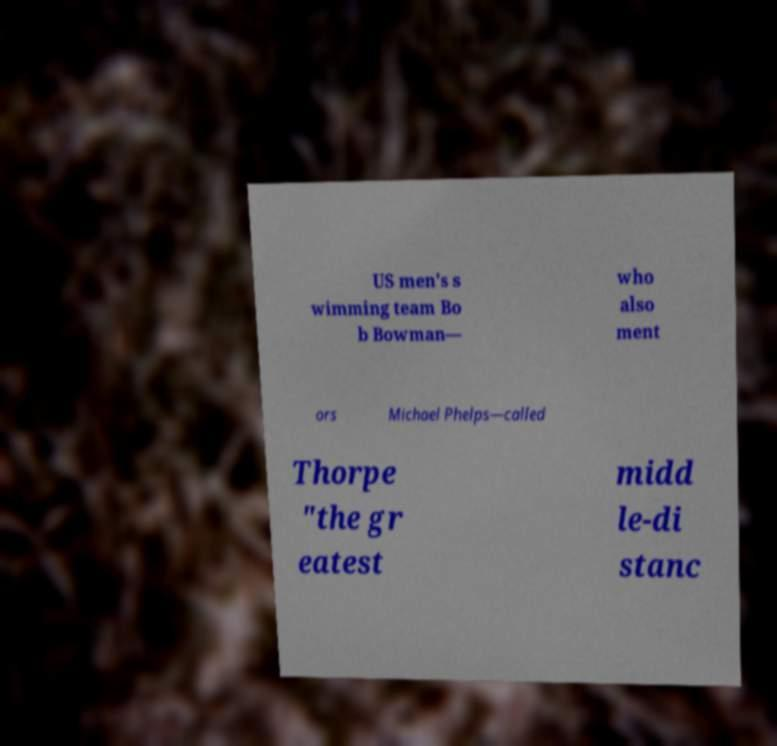I need the written content from this picture converted into text. Can you do that? US men's s wimming team Bo b Bowman— who also ment ors Michael Phelps—called Thorpe "the gr eatest midd le-di stanc 